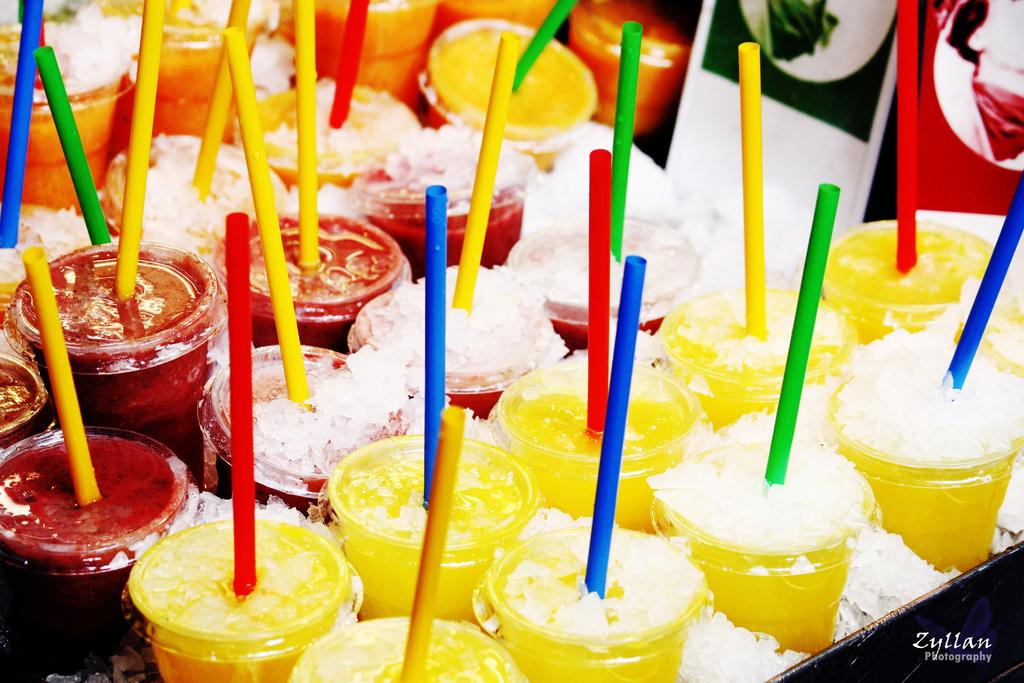What type of containers are visible in the image? There are cups in the image. What can be used to drink from the cups? There are straws in the image that can be used to drink from the cups. What is present in the cups that might be related to the straws? There is ice in the image, which is often used in drinks. How many girls can be seen in the image? There are no girls present in the image. What is the purpose of the cups in the image? The purpose of the cups in the image cannot be determined without additional context or information. 